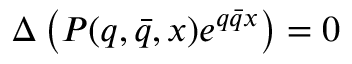<formula> <loc_0><loc_0><loc_500><loc_500>\Delta \left ( P ( q , \bar { q } , x ) e ^ { q \bar { q } x } \right ) = 0</formula> 